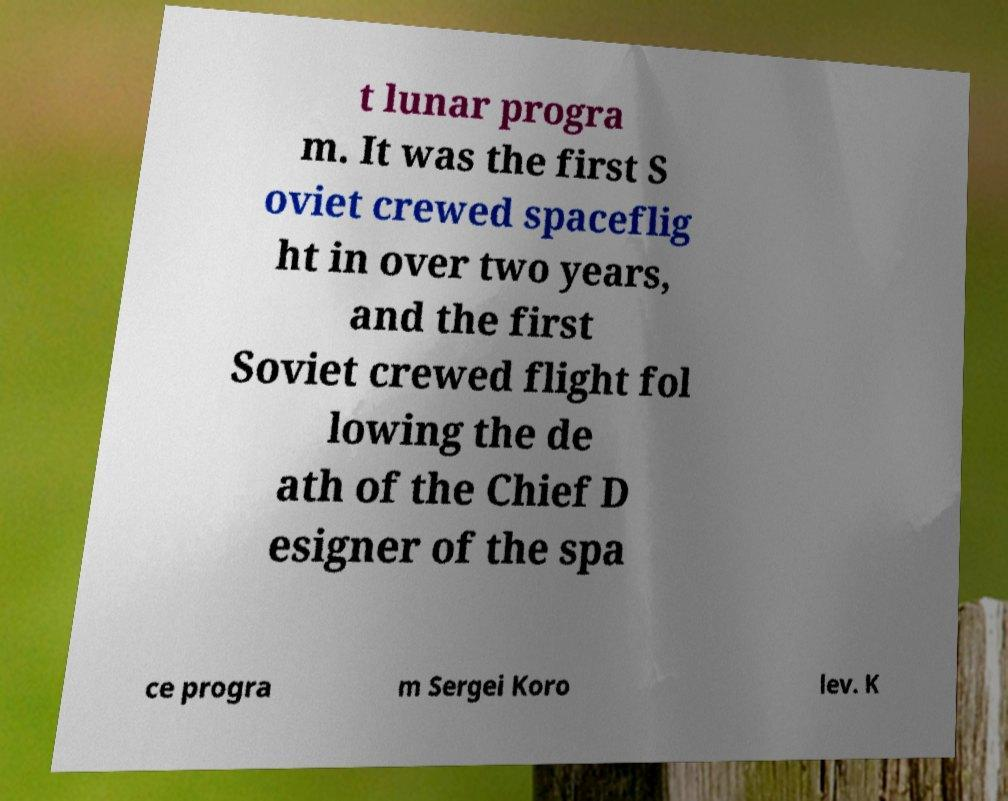What messages or text are displayed in this image? I need them in a readable, typed format. t lunar progra m. It was the first S oviet crewed spaceflig ht in over two years, and the first Soviet crewed flight fol lowing the de ath of the Chief D esigner of the spa ce progra m Sergei Koro lev. K 